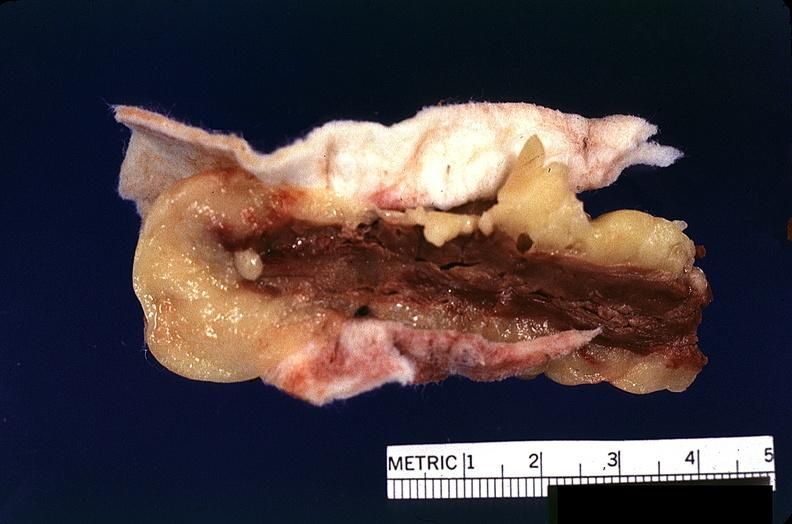s lesion present?
Answer the question using a single word or phrase. No 